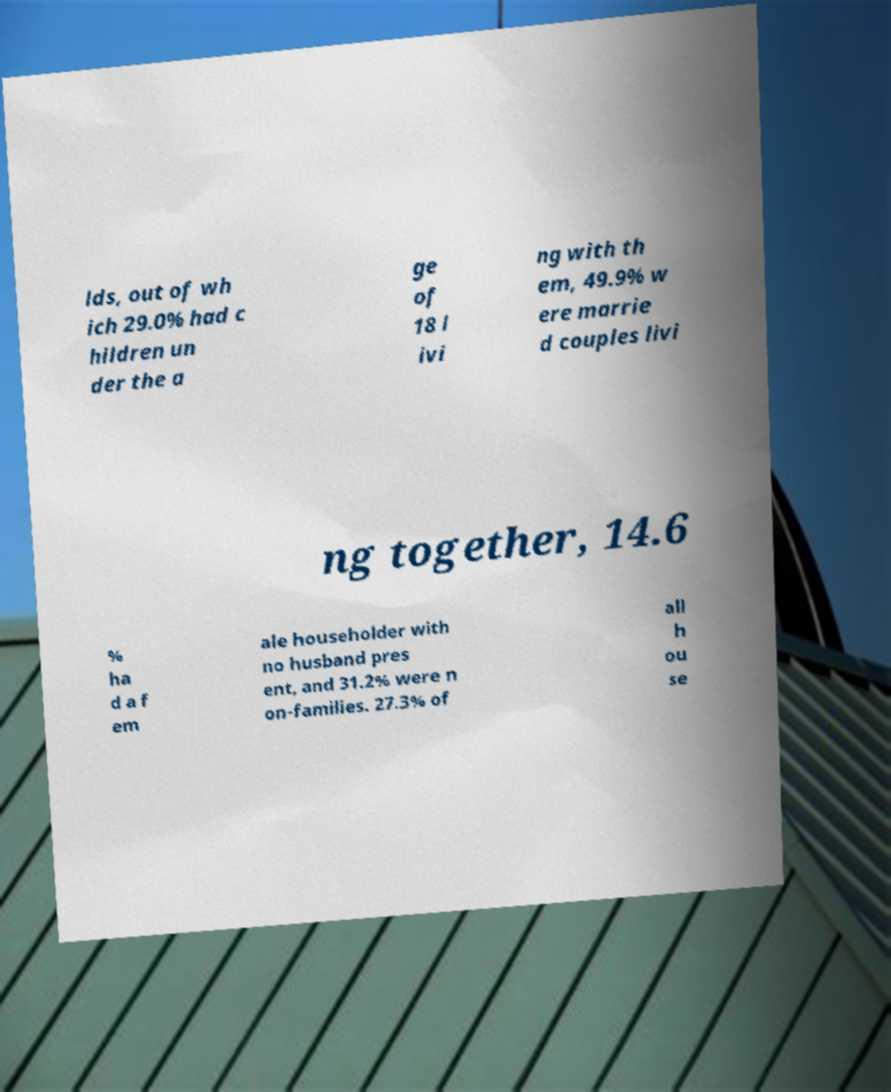There's text embedded in this image that I need extracted. Can you transcribe it verbatim? lds, out of wh ich 29.0% had c hildren un der the a ge of 18 l ivi ng with th em, 49.9% w ere marrie d couples livi ng together, 14.6 % ha d a f em ale householder with no husband pres ent, and 31.2% were n on-families. 27.3% of all h ou se 